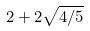Convert formula to latex. <formula><loc_0><loc_0><loc_500><loc_500>2 + 2 \sqrt { 4 / 5 }</formula> 